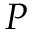<formula> <loc_0><loc_0><loc_500><loc_500>P</formula> 